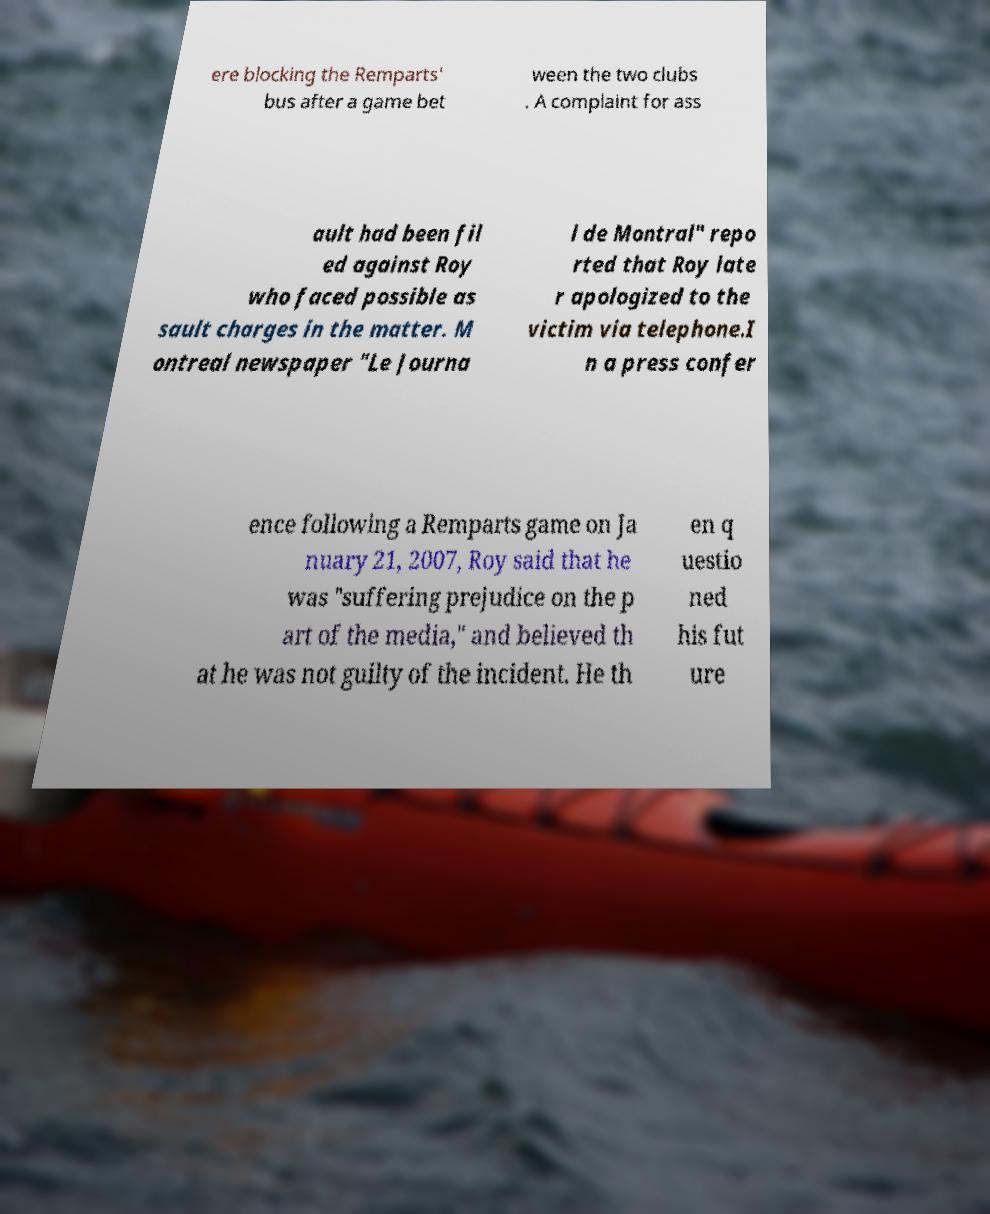What messages or text are displayed in this image? I need them in a readable, typed format. ere blocking the Remparts' bus after a game bet ween the two clubs . A complaint for ass ault had been fil ed against Roy who faced possible as sault charges in the matter. M ontreal newspaper "Le Journa l de Montral" repo rted that Roy late r apologized to the victim via telephone.I n a press confer ence following a Remparts game on Ja nuary 21, 2007, Roy said that he was "suffering prejudice on the p art of the media," and believed th at he was not guilty of the incident. He th en q uestio ned his fut ure 